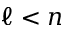<formula> <loc_0><loc_0><loc_500><loc_500>\ell < n</formula> 